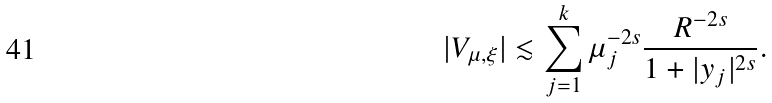<formula> <loc_0><loc_0><loc_500><loc_500>| V _ { \mu , \xi } | \lesssim \sum _ { j = 1 } ^ { k } \mu _ { j } ^ { - 2 s } \frac { R ^ { - 2 s } } { 1 + | y _ { j } | ^ { 2 s } } .</formula> 